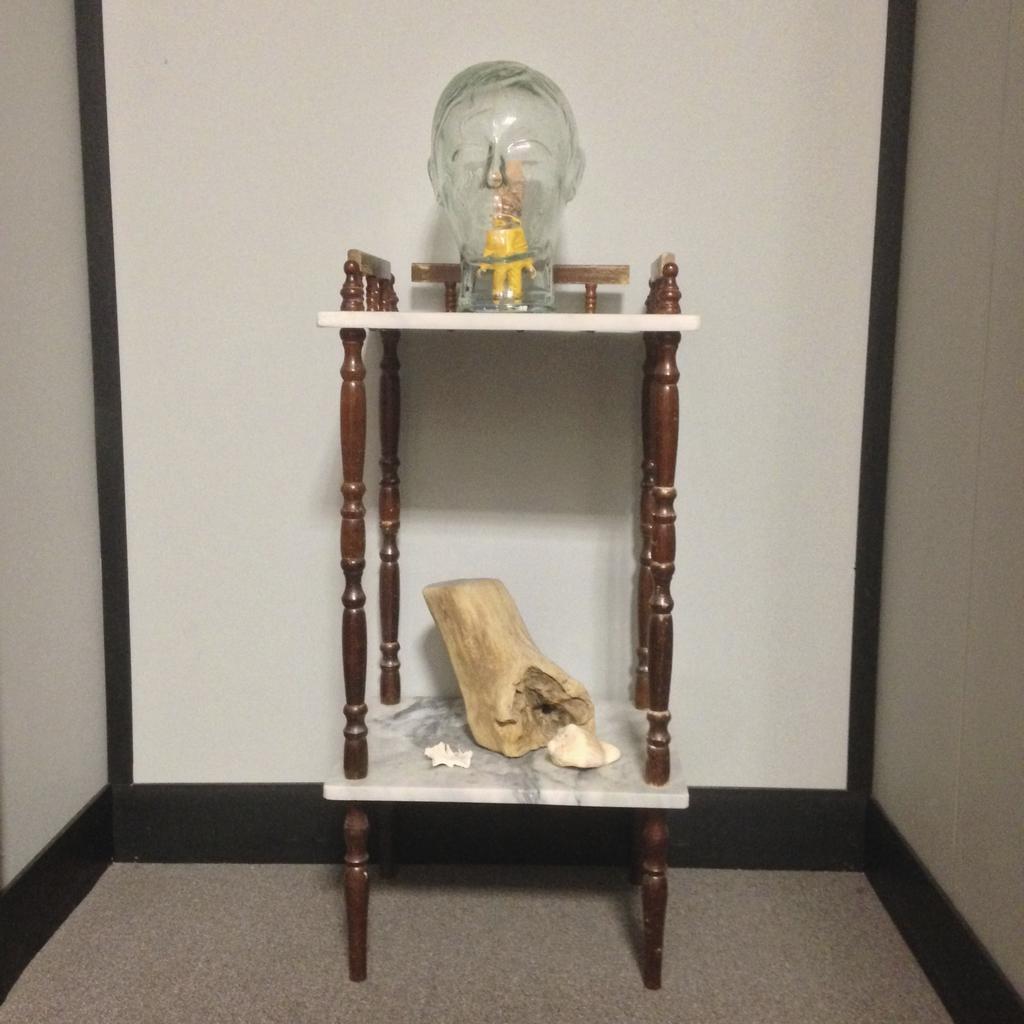Could you give a brief overview of what you see in this image? This image is taken indoors. In the background there is a wall. At the bottom of the image there is a floor. In the middle of the image there is a rack. There is a show piece on the rack and there is an object on the shelf. 